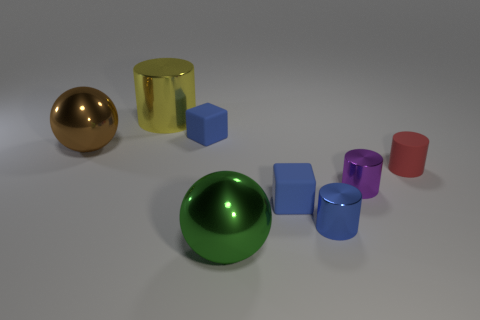Are there any blue matte objects that have the same size as the red thing?
Make the answer very short. Yes. Is the shape of the tiny blue shiny object the same as the tiny matte object to the right of the blue shiny object?
Give a very brief answer. Yes. There is a blue block right of the small blue block on the left side of the green thing; is there a big brown object that is behind it?
Provide a succinct answer. Yes. The brown sphere is what size?
Offer a very short reply. Large. How many other things are there of the same color as the large cylinder?
Give a very brief answer. 0. Does the blue rubber object that is to the right of the green sphere have the same shape as the purple thing?
Offer a very short reply. No. There is another object that is the same shape as the brown thing; what is its color?
Your answer should be compact. Green. The purple metal object that is the same shape as the yellow metal object is what size?
Keep it short and to the point. Small. What is the tiny object that is both on the left side of the blue cylinder and in front of the matte cylinder made of?
Your response must be concise. Rubber. There is a tiny cylinder that is in front of the small purple metal cylinder; is its color the same as the large shiny cylinder?
Make the answer very short. No. 